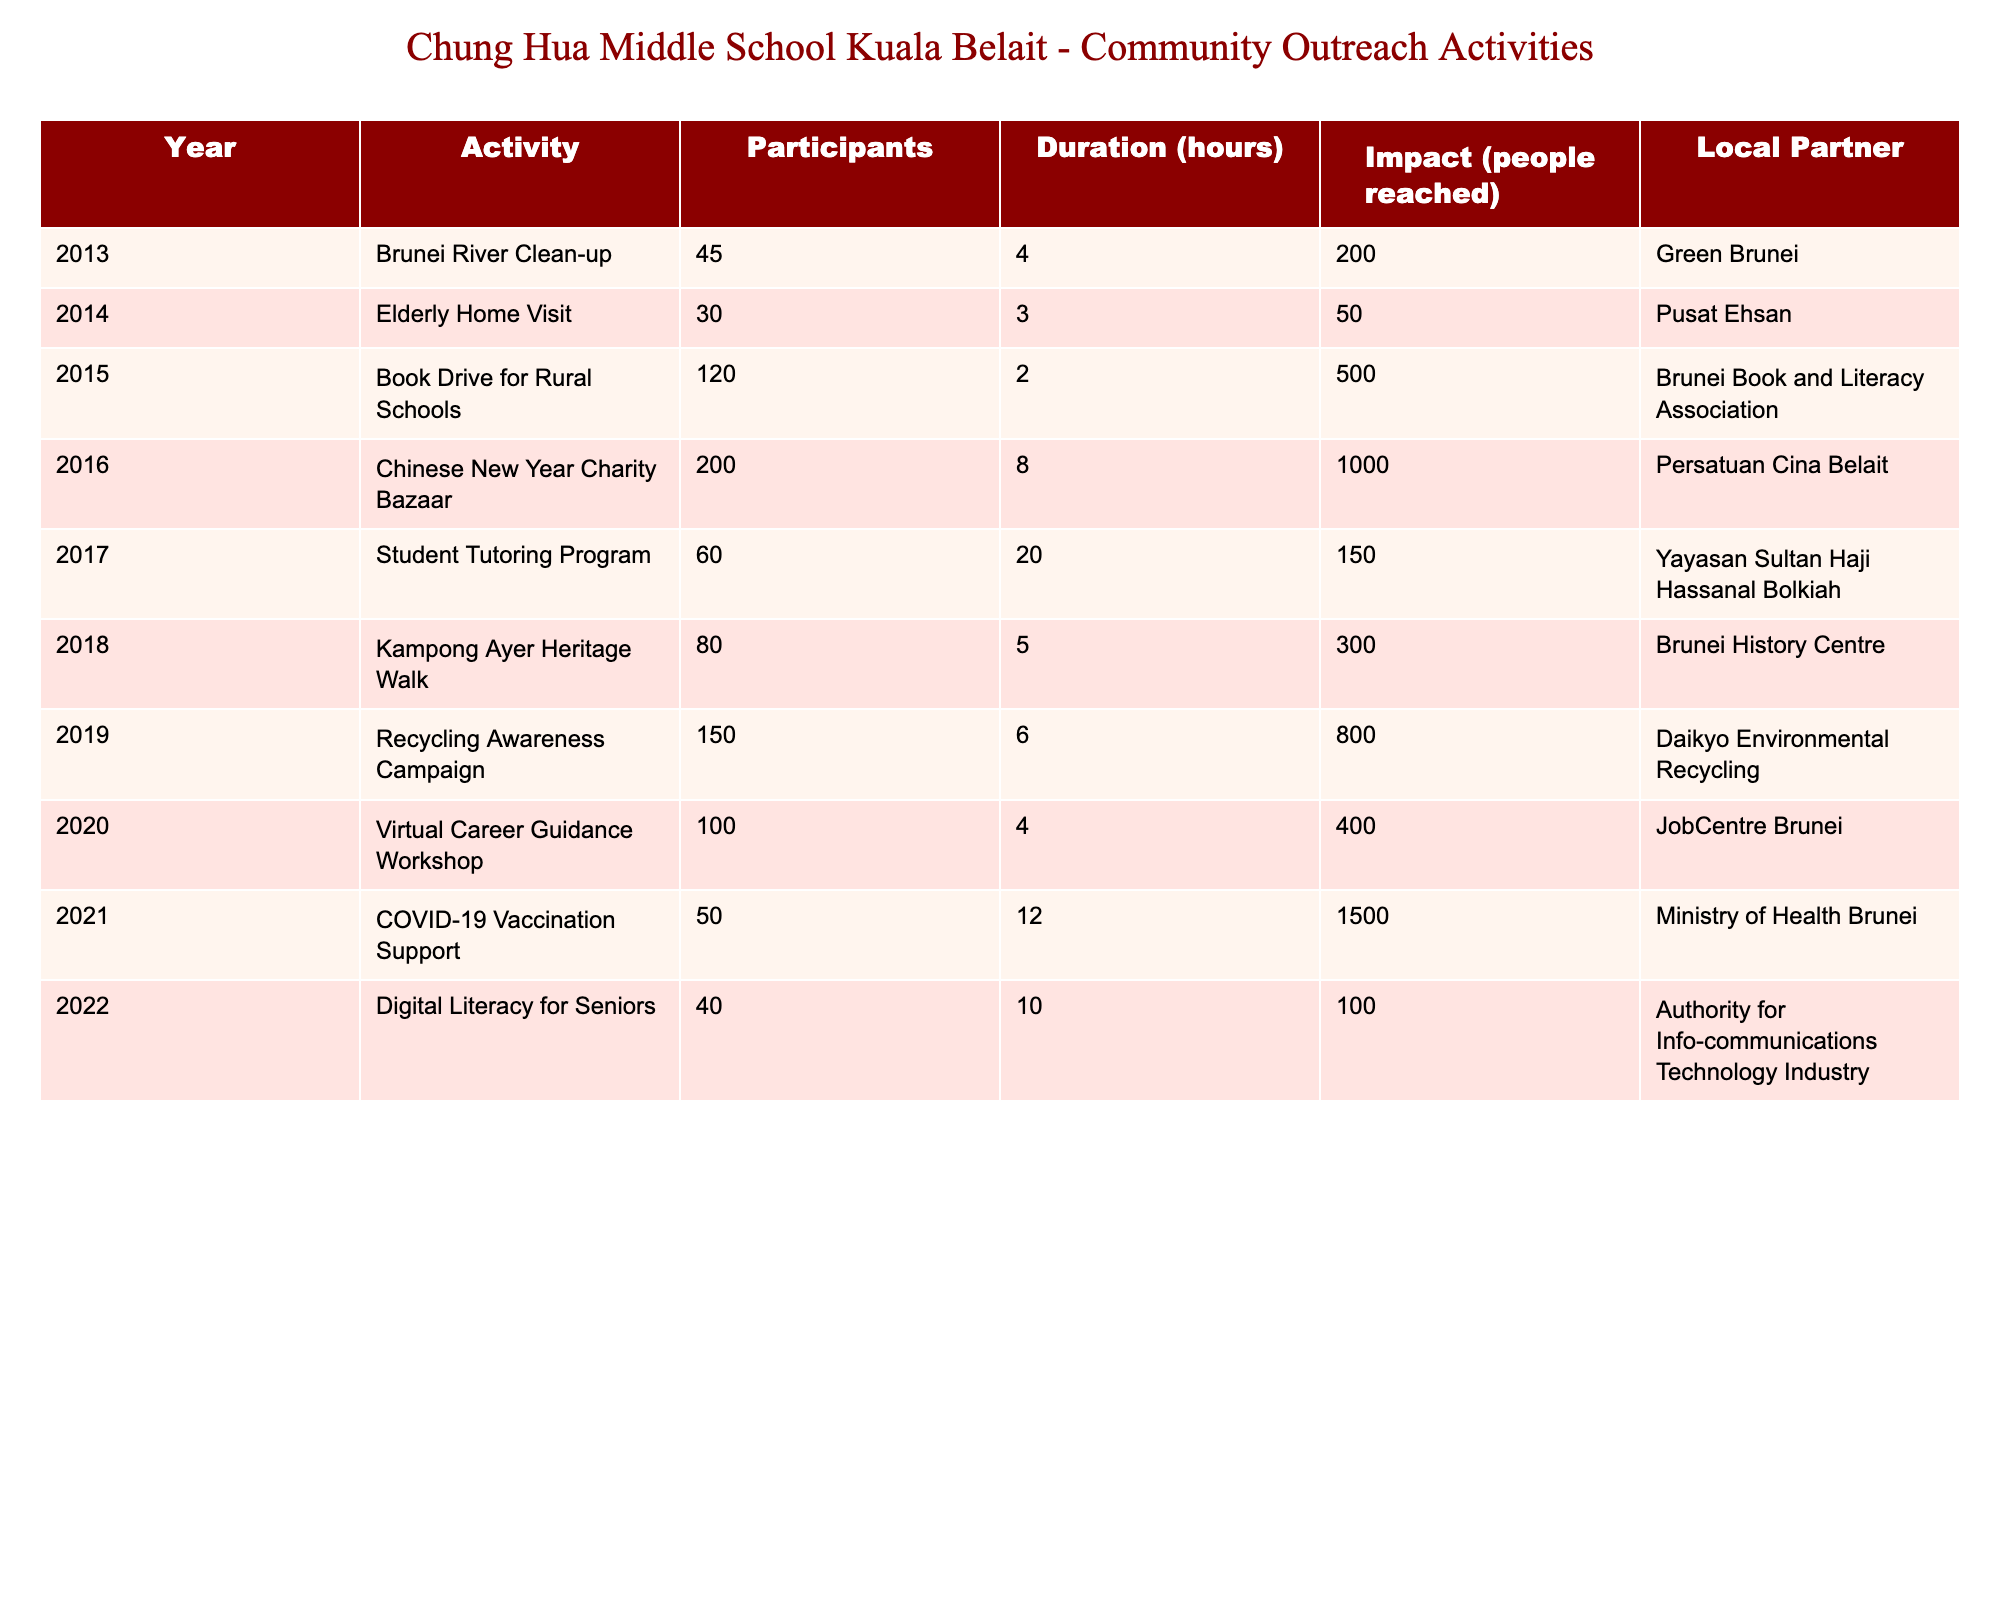What was the highest number of participants in a single activity? The activity with the highest number of participants is the "Chinese New Year Charity Bazaar" in 2016, which had 200 participants.
Answer: 200 What was the total impact on people reached across all activities from 2013 to 2022? To find the total impact, we sum up the numbers in the "Impact" column: 200 + 50 + 500 + 1000 + 150 + 300 + 800 + 400 + 1500 + 100 = 4150.
Answer: 4150 Which activity had the longest duration, and how long was it? The "Student Tutoring Program" in 2017 had the longest duration of 20 hours.
Answer: 20 hours Did the school have more participants in community outreach activities in 2019 compared to 2020? In 2019, there were 150 participants in the "Recycling Awareness Campaign," whereas in 2020, there were 100 participants in the "Virtual Career Guidance Workshop." Therefore, there were more participants in 2019.
Answer: Yes What was the average impact of all activities organized in 2021 and 2022? The impact for 2021 is 1500 and for 2022 is 100, so to find the average: (1500 + 100) / 2 = 800.
Answer: 800 How many local partners were involved in outreach activities in 2018 and 2022 combined? In both years, "Kampong Ayer Heritage Walk" (2018) and "Digital Literacy for Seniors" (2022) had local partners: Brunei History Centre and Authority for Info-communications Technology Industry, respectively. Therefore, there were 2 local partners involved.
Answer: 2 Which year had the least number of participants, and how many were there? The year 2014 had the least number of participants in the "Elderly Home Visit" with 30 participants.
Answer: 30 What percentage of the total impact was reached in 2021? The total impact is 4150, and the impact for 2021 is 1500. Calculating the percentage: (1500 / 4150) * 100 = 36.14%.
Answer: 36.14% Which activity was conducted in the year with the highest recorded impact? The "COVID-19 Vaccination Support" activity in 2021 had the highest recorded impact of 1500 people reached.
Answer: COVID-19 Vaccination Support How many activities involved local partners focused on education? The activities "Student Tutoring Program" (2017) and "Book Drive for Rural Schools" (2015) focused on education; hence, there were 2 activities.
Answer: 2 What is the difference in the number of participants between the "Book Drive for Rural Schools" and the "Chinese New Year Charity Bazaar"? The "Book Drive for Rural Schools" had 120 participants, while the "Chinese New Year Charity Bazaar" had 200 participants. The difference is 200 - 120 = 80.
Answer: 80 